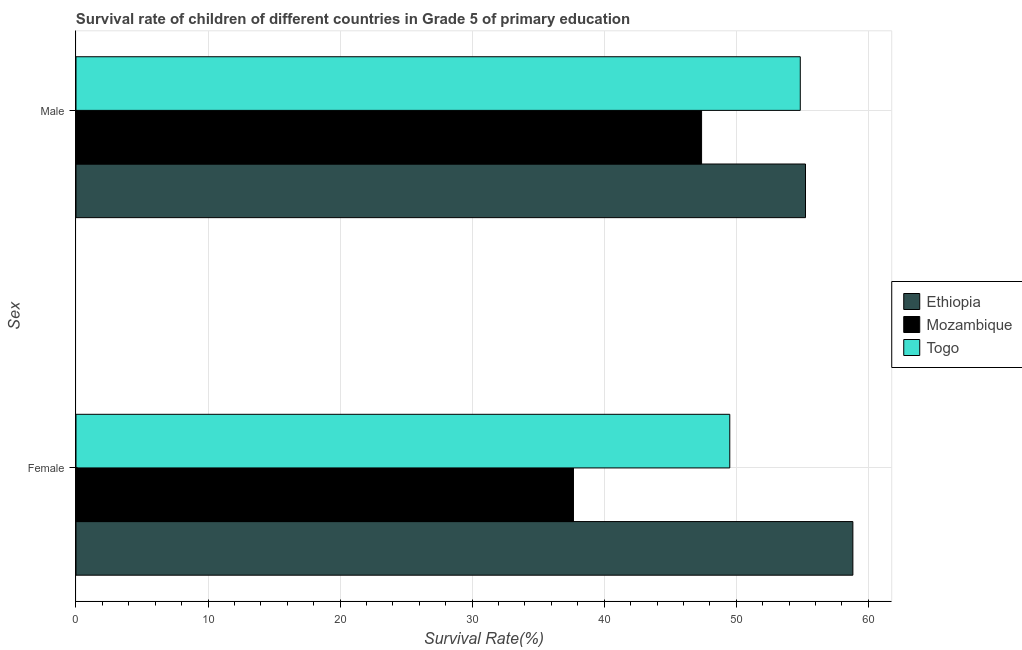How many different coloured bars are there?
Your answer should be very brief. 3. How many groups of bars are there?
Make the answer very short. 2. Are the number of bars on each tick of the Y-axis equal?
Make the answer very short. Yes. How many bars are there on the 2nd tick from the top?
Make the answer very short. 3. How many bars are there on the 2nd tick from the bottom?
Offer a terse response. 3. What is the label of the 1st group of bars from the top?
Give a very brief answer. Male. What is the survival rate of male students in primary education in Togo?
Provide a succinct answer. 54.85. Across all countries, what is the maximum survival rate of female students in primary education?
Provide a short and direct response. 58.83. Across all countries, what is the minimum survival rate of female students in primary education?
Offer a terse response. 37.67. In which country was the survival rate of male students in primary education maximum?
Your answer should be compact. Ethiopia. In which country was the survival rate of female students in primary education minimum?
Keep it short and to the point. Mozambique. What is the total survival rate of male students in primary education in the graph?
Ensure brevity in your answer.  157.47. What is the difference between the survival rate of male students in primary education in Mozambique and that in Togo?
Keep it short and to the point. -7.47. What is the difference between the survival rate of female students in primary education in Mozambique and the survival rate of male students in primary education in Ethiopia?
Ensure brevity in your answer.  -17.57. What is the average survival rate of female students in primary education per country?
Your answer should be compact. 48.67. What is the difference between the survival rate of female students in primary education and survival rate of male students in primary education in Mozambique?
Offer a very short reply. -9.7. What is the ratio of the survival rate of female students in primary education in Ethiopia to that in Togo?
Give a very brief answer. 1.19. Is the survival rate of female students in primary education in Mozambique less than that in Ethiopia?
Make the answer very short. Yes. In how many countries, is the survival rate of female students in primary education greater than the average survival rate of female students in primary education taken over all countries?
Offer a terse response. 2. What does the 3rd bar from the top in Male represents?
Keep it short and to the point. Ethiopia. What does the 3rd bar from the bottom in Female represents?
Make the answer very short. Togo. Are all the bars in the graph horizontal?
Ensure brevity in your answer.  Yes. Does the graph contain any zero values?
Make the answer very short. No. Does the graph contain grids?
Offer a very short reply. Yes. How many legend labels are there?
Your response must be concise. 3. What is the title of the graph?
Ensure brevity in your answer.  Survival rate of children of different countries in Grade 5 of primary education. What is the label or title of the X-axis?
Provide a succinct answer. Survival Rate(%). What is the label or title of the Y-axis?
Provide a short and direct response. Sex. What is the Survival Rate(%) of Ethiopia in Female?
Your response must be concise. 58.83. What is the Survival Rate(%) in Mozambique in Female?
Provide a succinct answer. 37.67. What is the Survival Rate(%) of Togo in Female?
Keep it short and to the point. 49.51. What is the Survival Rate(%) of Ethiopia in Male?
Offer a terse response. 55.25. What is the Survival Rate(%) in Mozambique in Male?
Offer a very short reply. 47.38. What is the Survival Rate(%) in Togo in Male?
Keep it short and to the point. 54.85. Across all Sex, what is the maximum Survival Rate(%) of Ethiopia?
Provide a short and direct response. 58.83. Across all Sex, what is the maximum Survival Rate(%) of Mozambique?
Offer a very short reply. 47.38. Across all Sex, what is the maximum Survival Rate(%) in Togo?
Give a very brief answer. 54.85. Across all Sex, what is the minimum Survival Rate(%) in Ethiopia?
Your answer should be very brief. 55.25. Across all Sex, what is the minimum Survival Rate(%) in Mozambique?
Provide a succinct answer. 37.67. Across all Sex, what is the minimum Survival Rate(%) of Togo?
Provide a short and direct response. 49.51. What is the total Survival Rate(%) of Ethiopia in the graph?
Your answer should be compact. 114.08. What is the total Survival Rate(%) of Mozambique in the graph?
Offer a very short reply. 85.05. What is the total Survival Rate(%) of Togo in the graph?
Offer a very short reply. 104.36. What is the difference between the Survival Rate(%) of Ethiopia in Female and that in Male?
Offer a terse response. 3.59. What is the difference between the Survival Rate(%) in Mozambique in Female and that in Male?
Provide a succinct answer. -9.7. What is the difference between the Survival Rate(%) in Togo in Female and that in Male?
Your response must be concise. -5.34. What is the difference between the Survival Rate(%) of Ethiopia in Female and the Survival Rate(%) of Mozambique in Male?
Ensure brevity in your answer.  11.46. What is the difference between the Survival Rate(%) in Ethiopia in Female and the Survival Rate(%) in Togo in Male?
Keep it short and to the point. 3.98. What is the difference between the Survival Rate(%) of Mozambique in Female and the Survival Rate(%) of Togo in Male?
Your response must be concise. -17.18. What is the average Survival Rate(%) in Ethiopia per Sex?
Provide a short and direct response. 57.04. What is the average Survival Rate(%) in Mozambique per Sex?
Ensure brevity in your answer.  42.52. What is the average Survival Rate(%) of Togo per Sex?
Provide a succinct answer. 52.18. What is the difference between the Survival Rate(%) in Ethiopia and Survival Rate(%) in Mozambique in Female?
Give a very brief answer. 21.16. What is the difference between the Survival Rate(%) in Ethiopia and Survival Rate(%) in Togo in Female?
Give a very brief answer. 9.32. What is the difference between the Survival Rate(%) in Mozambique and Survival Rate(%) in Togo in Female?
Your answer should be very brief. -11.84. What is the difference between the Survival Rate(%) in Ethiopia and Survival Rate(%) in Mozambique in Male?
Make the answer very short. 7.87. What is the difference between the Survival Rate(%) in Ethiopia and Survival Rate(%) in Togo in Male?
Offer a very short reply. 0.4. What is the difference between the Survival Rate(%) in Mozambique and Survival Rate(%) in Togo in Male?
Your answer should be compact. -7.47. What is the ratio of the Survival Rate(%) in Ethiopia in Female to that in Male?
Your response must be concise. 1.06. What is the ratio of the Survival Rate(%) of Mozambique in Female to that in Male?
Ensure brevity in your answer.  0.8. What is the ratio of the Survival Rate(%) of Togo in Female to that in Male?
Provide a short and direct response. 0.9. What is the difference between the highest and the second highest Survival Rate(%) of Ethiopia?
Provide a short and direct response. 3.59. What is the difference between the highest and the second highest Survival Rate(%) in Mozambique?
Make the answer very short. 9.7. What is the difference between the highest and the second highest Survival Rate(%) of Togo?
Your answer should be compact. 5.34. What is the difference between the highest and the lowest Survival Rate(%) in Ethiopia?
Offer a terse response. 3.59. What is the difference between the highest and the lowest Survival Rate(%) of Mozambique?
Your answer should be very brief. 9.7. What is the difference between the highest and the lowest Survival Rate(%) of Togo?
Make the answer very short. 5.34. 